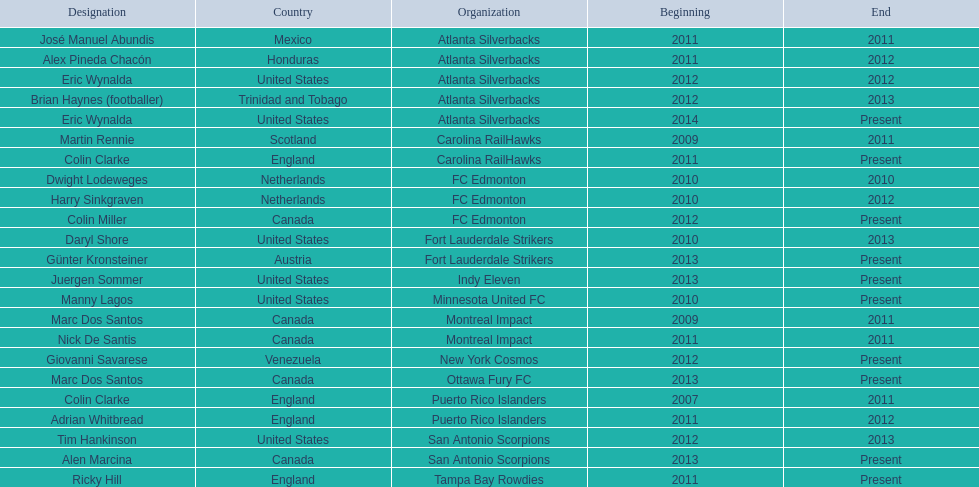What year did marc dos santos start as coach? 2009. Which other starting years correspond with this year? 2009. Who was the other coach with this starting year Martin Rennie. 